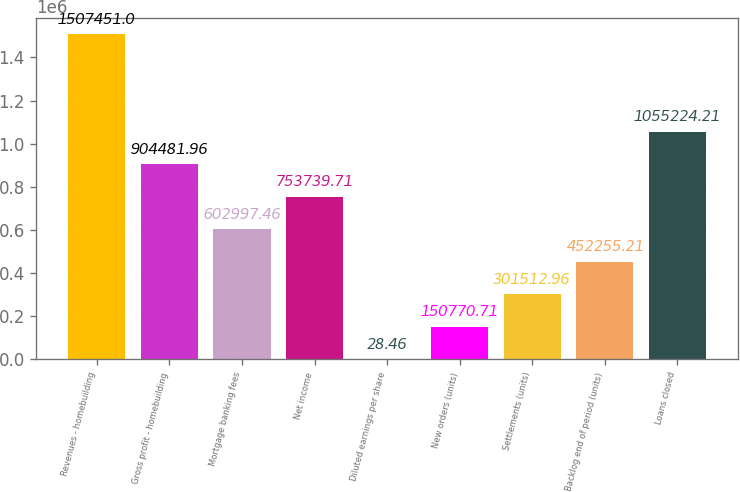Convert chart to OTSL. <chart><loc_0><loc_0><loc_500><loc_500><bar_chart><fcel>Revenues - homebuilding<fcel>Gross profit - homebuilding<fcel>Mortgage banking fees<fcel>Net income<fcel>Diluted earnings per share<fcel>New orders (units)<fcel>Settlements (units)<fcel>Backlog end of period (units)<fcel>Loans closed<nl><fcel>1.50745e+06<fcel>904482<fcel>602997<fcel>753740<fcel>28.46<fcel>150771<fcel>301513<fcel>452255<fcel>1.05522e+06<nl></chart> 